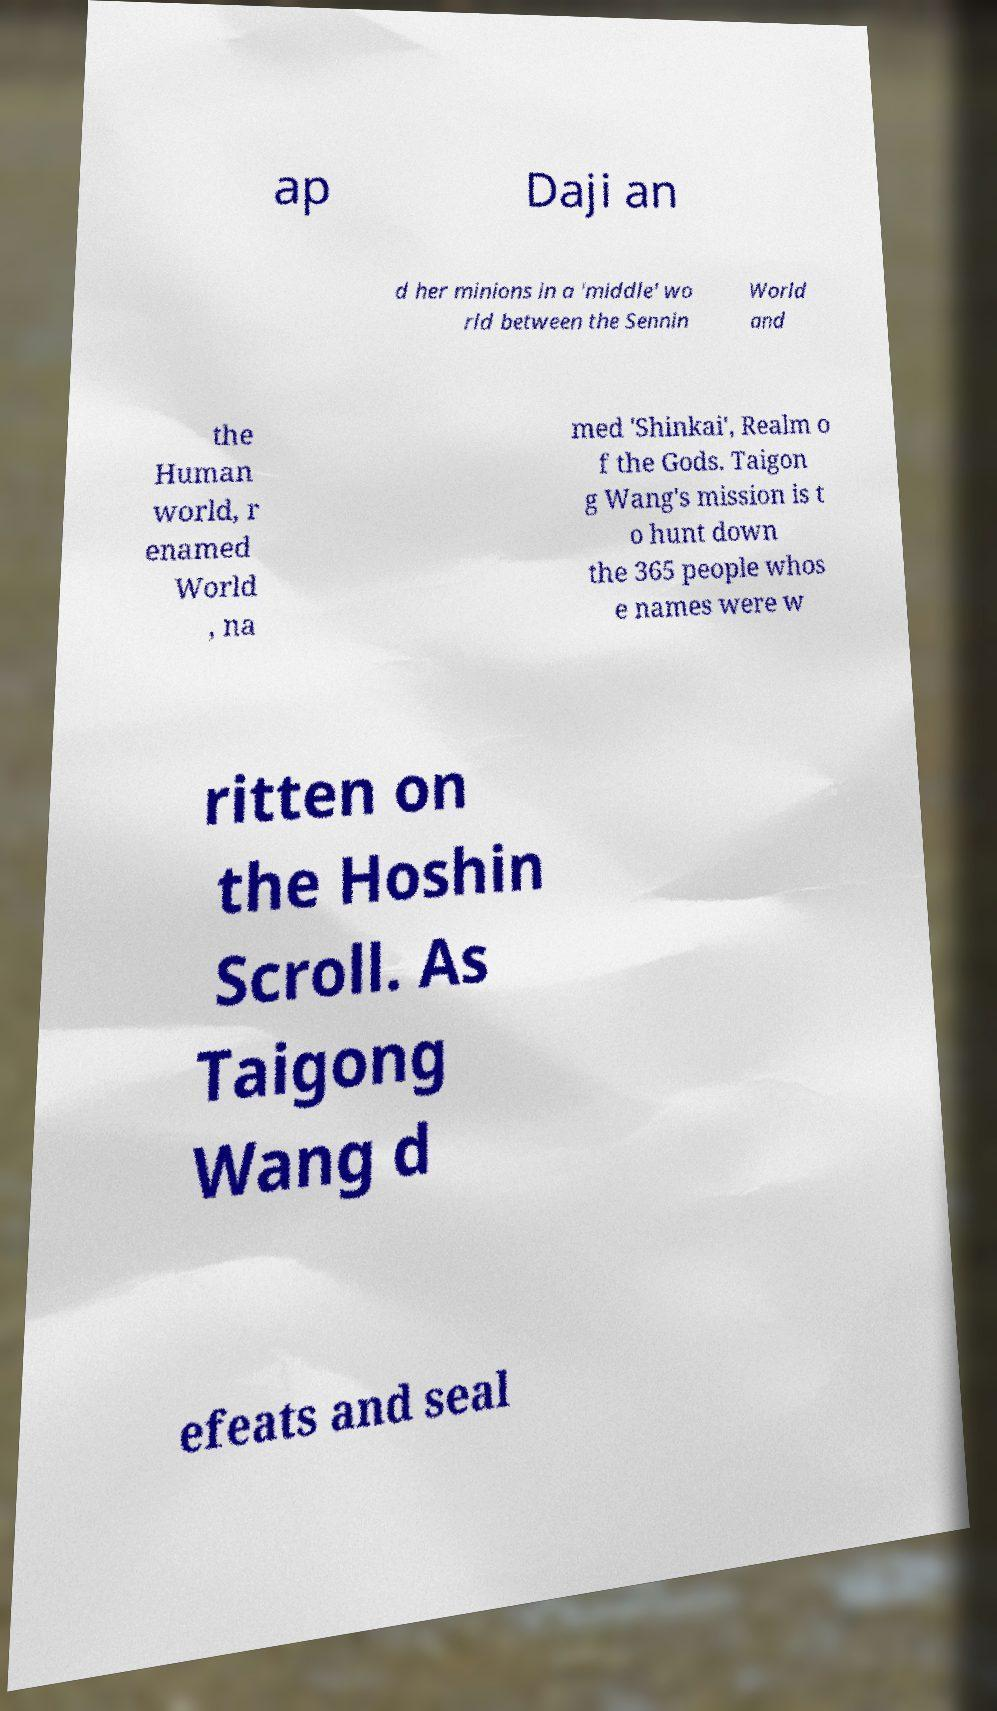What messages or text are displayed in this image? I need them in a readable, typed format. ap Daji an d her minions in a 'middle' wo rld between the Sennin World and the Human world, r enamed World , na med 'Shinkai', Realm o f the Gods. Taigon g Wang's mission is t o hunt down the 365 people whos e names were w ritten on the Hoshin Scroll. As Taigong Wang d efeats and seal 